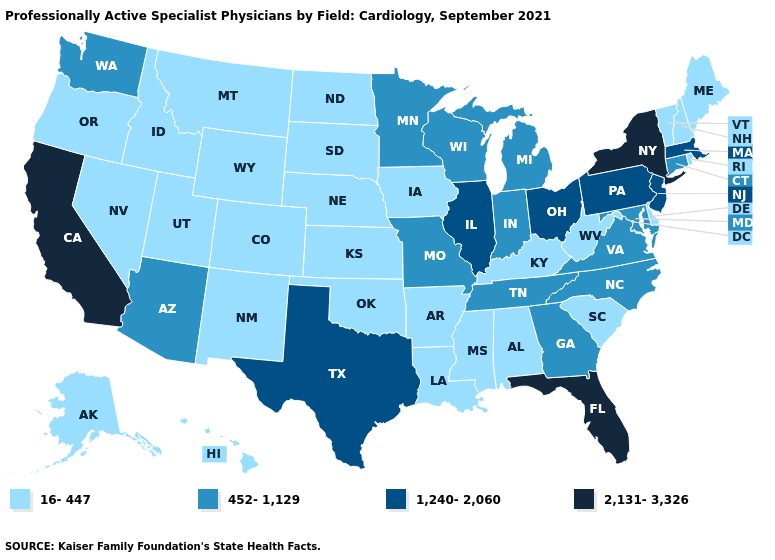Among the states that border Connecticut , which have the highest value?
Answer briefly. New York. What is the highest value in the MidWest ?
Short answer required. 1,240-2,060. Among the states that border Florida , which have the lowest value?
Be succinct. Alabama. What is the lowest value in the West?
Concise answer only. 16-447. Does Tennessee have the lowest value in the South?
Concise answer only. No. Name the states that have a value in the range 1,240-2,060?
Keep it brief. Illinois, Massachusetts, New Jersey, Ohio, Pennsylvania, Texas. Among the states that border Indiana , which have the lowest value?
Give a very brief answer. Kentucky. Which states have the lowest value in the Northeast?
Keep it brief. Maine, New Hampshire, Rhode Island, Vermont. Does Kansas have a higher value than Maryland?
Be succinct. No. Name the states that have a value in the range 16-447?
Keep it brief. Alabama, Alaska, Arkansas, Colorado, Delaware, Hawaii, Idaho, Iowa, Kansas, Kentucky, Louisiana, Maine, Mississippi, Montana, Nebraska, Nevada, New Hampshire, New Mexico, North Dakota, Oklahoma, Oregon, Rhode Island, South Carolina, South Dakota, Utah, Vermont, West Virginia, Wyoming. Which states have the highest value in the USA?
Quick response, please. California, Florida, New York. Name the states that have a value in the range 2,131-3,326?
Answer briefly. California, Florida, New York. What is the value of Arkansas?
Answer briefly. 16-447. Which states hav the highest value in the Northeast?
Keep it brief. New York. 